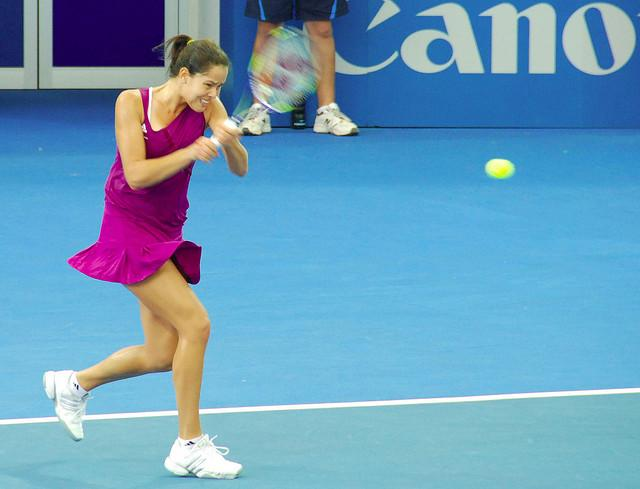What is the most likely reason for the word appearing on the wall behind the athlete? Please explain your reasoning. paid advertisement. The tournament is sponsored by this brand. 